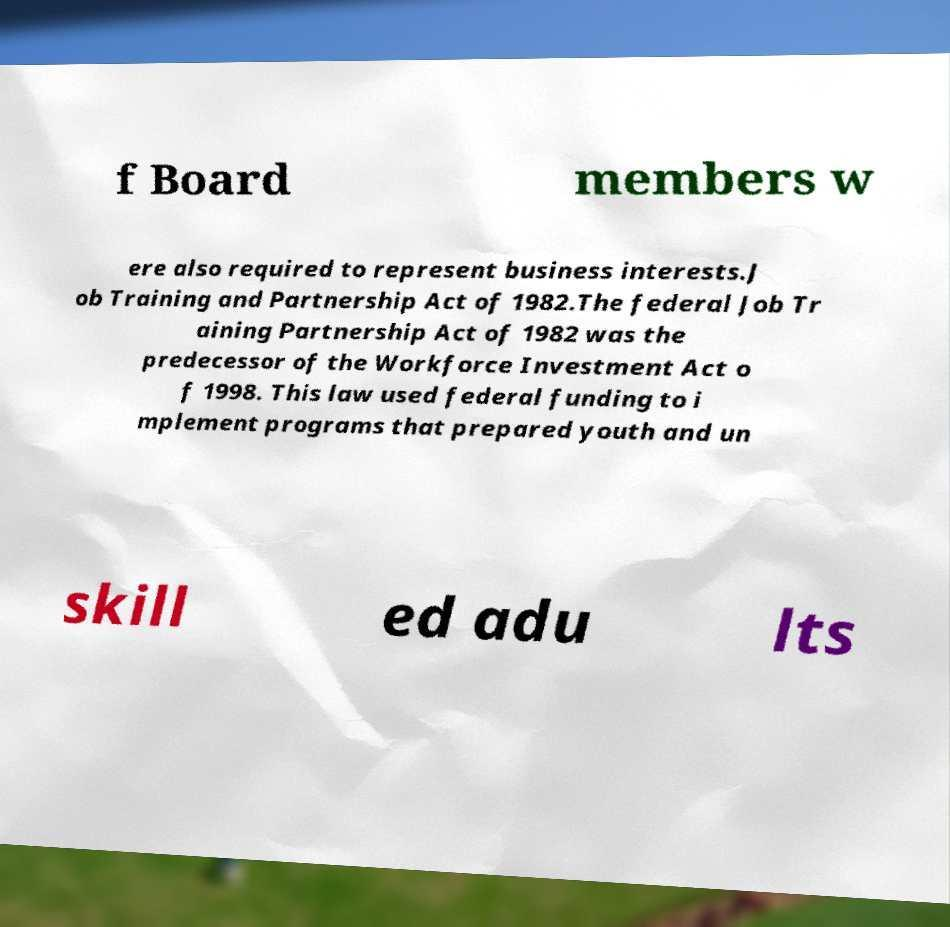Please read and relay the text visible in this image. What does it say? f Board members w ere also required to represent business interests.J ob Training and Partnership Act of 1982.The federal Job Tr aining Partnership Act of 1982 was the predecessor of the Workforce Investment Act o f 1998. This law used federal funding to i mplement programs that prepared youth and un skill ed adu lts 